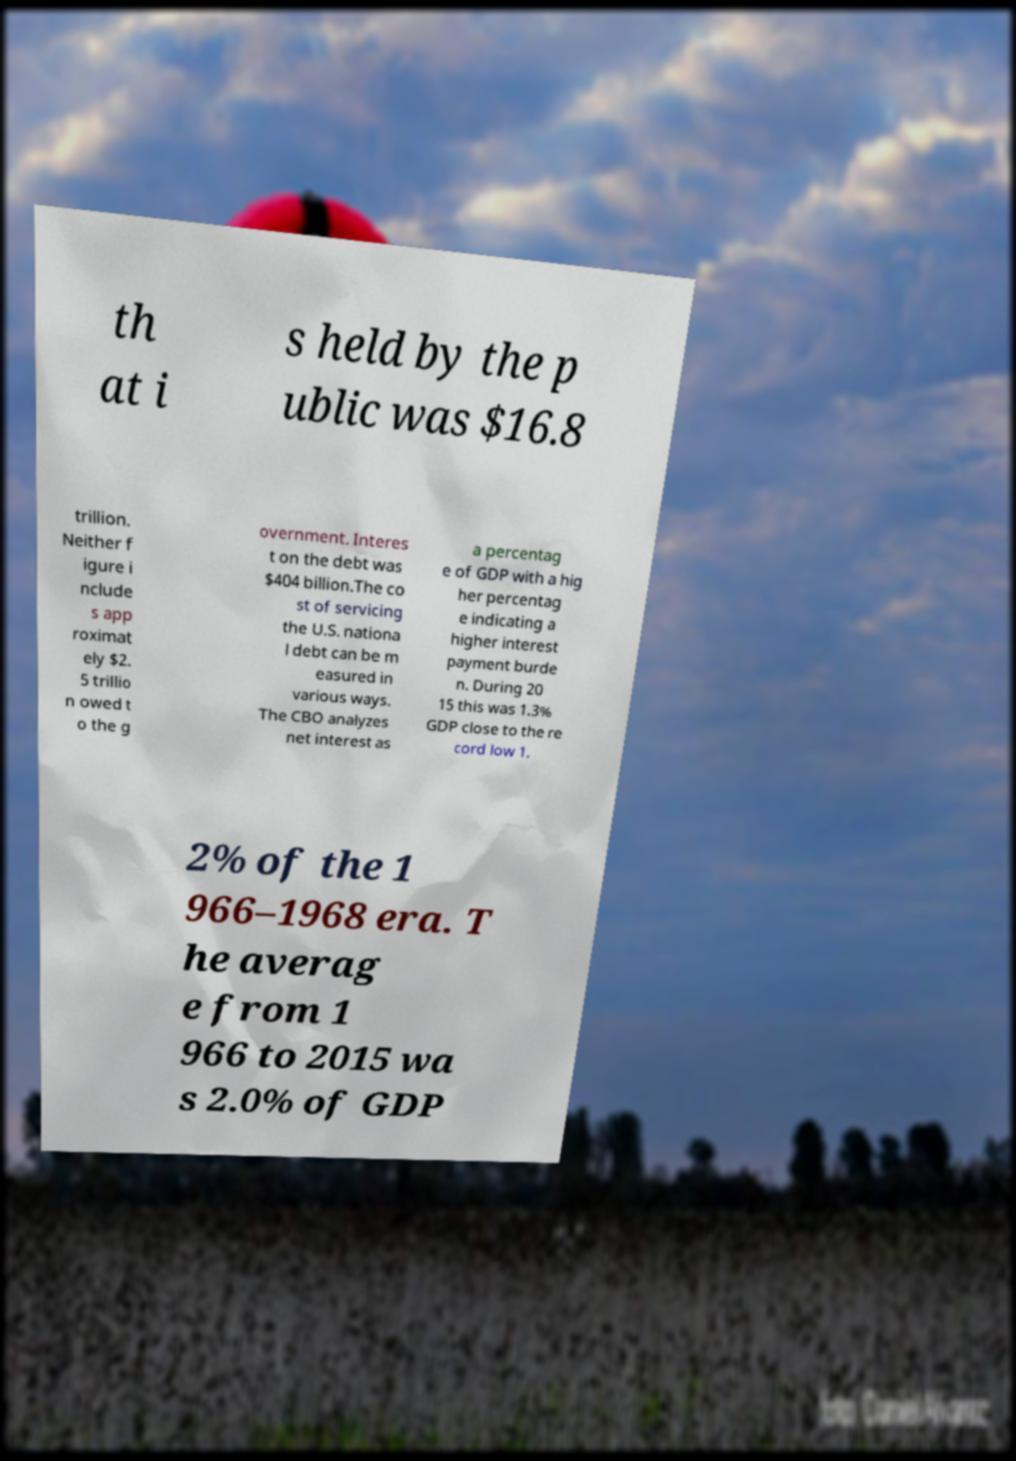There's text embedded in this image that I need extracted. Can you transcribe it verbatim? th at i s held by the p ublic was $16.8 trillion. Neither f igure i nclude s app roximat ely $2. 5 trillio n owed t o the g overnment. Interes t on the debt was $404 billion.The co st of servicing the U.S. nationa l debt can be m easured in various ways. The CBO analyzes net interest as a percentag e of GDP with a hig her percentag e indicating a higher interest payment burde n. During 20 15 this was 1.3% GDP close to the re cord low 1. 2% of the 1 966–1968 era. T he averag e from 1 966 to 2015 wa s 2.0% of GDP 